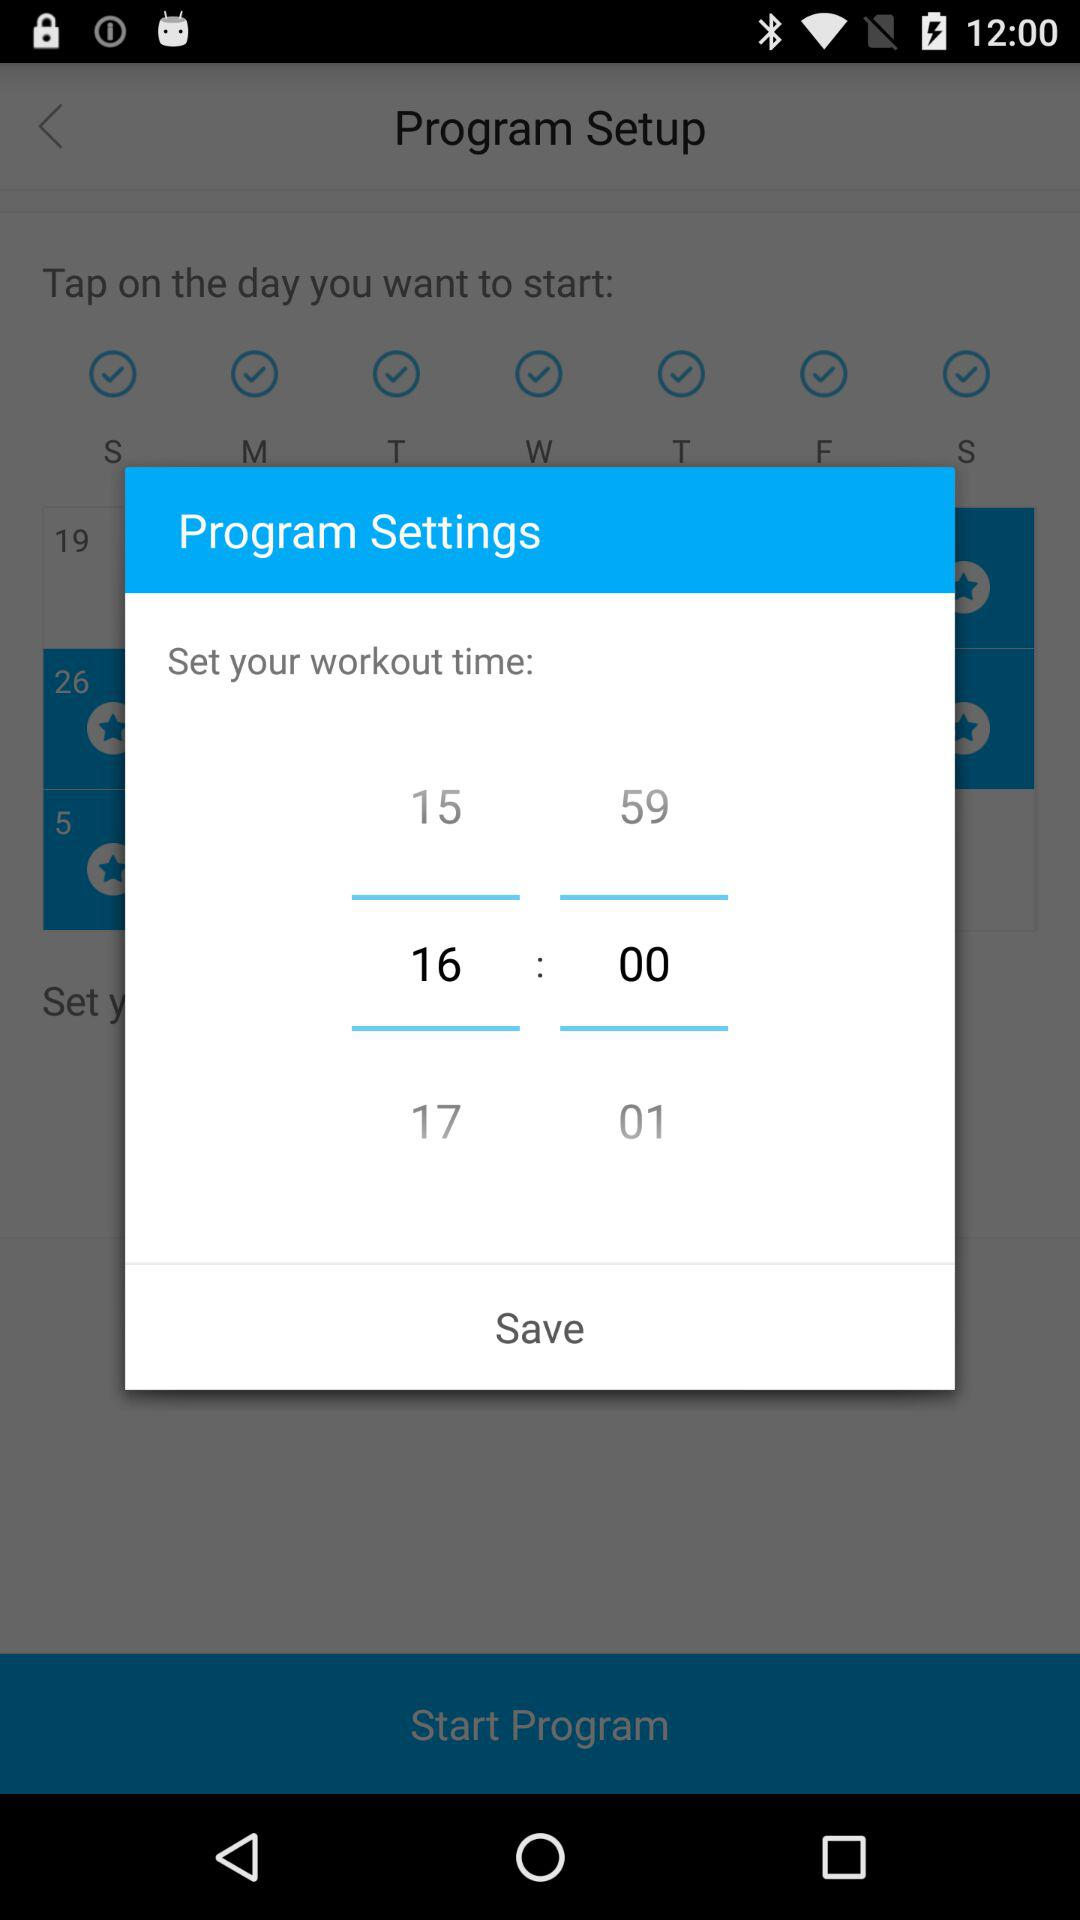How many minutes are in the shortest workout time?
Answer the question using a single word or phrase. 15 